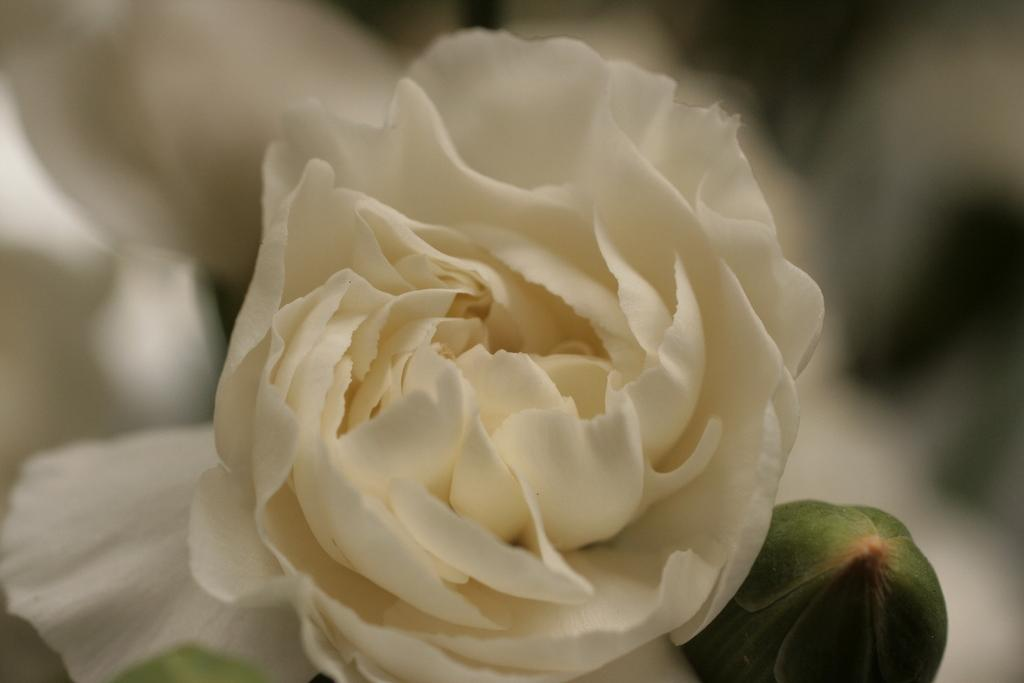What type of flower is in the image? There is a white rose in the image. Can you describe any other features of the flower? There is a bud in the bottom right of the image. What is the background of the image like? The background of the image is blurry. What type of locket can be seen hanging from the rose in the image? There is no locket present in the image; it only features a white rose and a bud. What is the best way to slip through the rose in the image? There is no way to slip through the rose in the image, as it is a static photograph. 